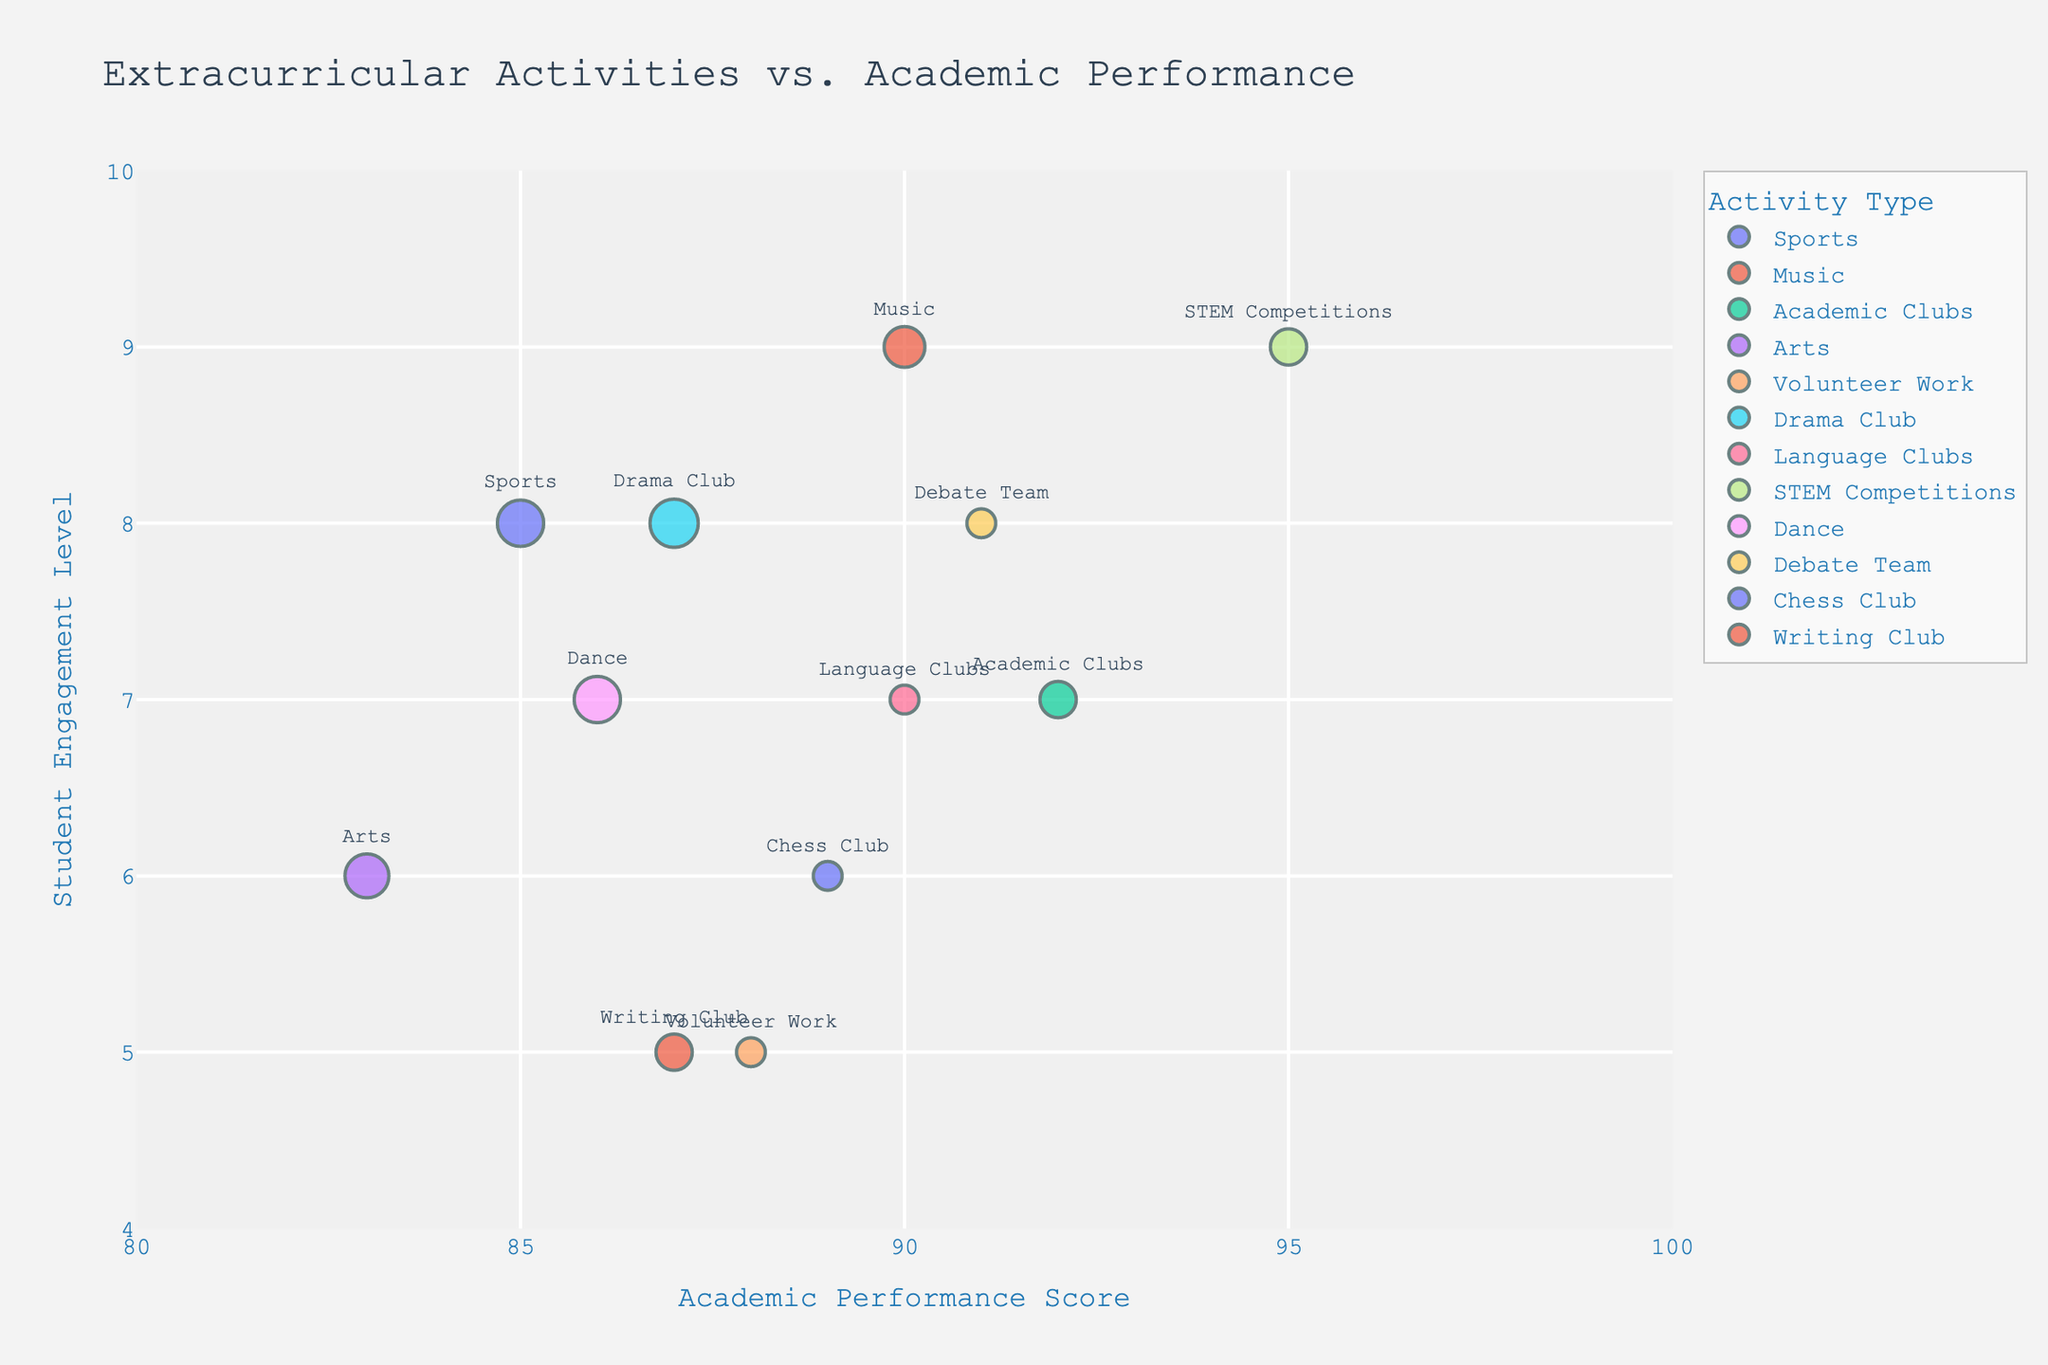What is the title of the bubble chart? The title is often prominently displayed at the top of the figure, providing a clear indication of what the chart represents. In this case, the title is "Extracurricular Activities vs. Academic Performance".
Answer: Extracurricular Activities vs. Academic Performance How many different activities are shown in the bubble chart? By counting the distinct labels on the bubbles, we can determine the number of different activities represented in the chart.
Answer: 12 Which activity has the highest Academic Performance score? To find the answer, look for the bubble with the highest value on the x-axis labeled "Academic Performance". The activity associated with this bubble is "STEM Competitions" which has a score of 95.
Answer: STEM Competitions What is the range of Engagement Levels displayed on the y-axis? The lowest and highest values on the y-axis determine the range. The y-axis ranges from approximately 4 to 10 according to the visual axis labels.
Answer: 4 to 10 Which school has the most hours per week for extracurricular activities? The size of the bubbles corresponds to the "Hours per Week". The largest bubble represents the "Drama Club" from Brookfield School, indicating it has the most hours per week.
Answer: Brookfield School (Drama Club) What is the Engagement Level for Music activities? Identify the bubble labeled "Music" and refer to its position on the y-axis to determine the Engagement Level. For Music, this level is at 9.
Answer: 9 Which activity has the lowest Engagement Level and what is that level? Scan the y-axis for the lowest positioned bubble. "Volunteer Work" has the lowest Engagement Level at 5.
Answer: Volunteer Work, 5 How does the Academic Performance of Sports compare to Music? Check the x-axis positions of the bubbles labeled "Sports" and "Music". Sports has a score of 85, while Music has a score of 90, indicating that Music has a higher Academic Performance.
Answer: Music has a higher Academic Performance Which activity from Riverdale High has a bubble on the chart and what is its Engagement Level? The hover-name feature indicates schools; locate the bubble for Riverdale High, which is labeled "Sports" with an Engagement Level of 8.
Answer: Sports, 8 What is the average Academic Performance score for activities with high engagement levels (8 or above)? Identify activities with Engagement Levels of 8 or higher, which are Sports, Music, Drama Club, Debate Team, and STEM Competitions. The scores are 85, 90, 87, 91, and 95. Calculate the average: (85 + 90 + 87 + 91 + 95)/5 = 89.6.
Answer: 89.6 